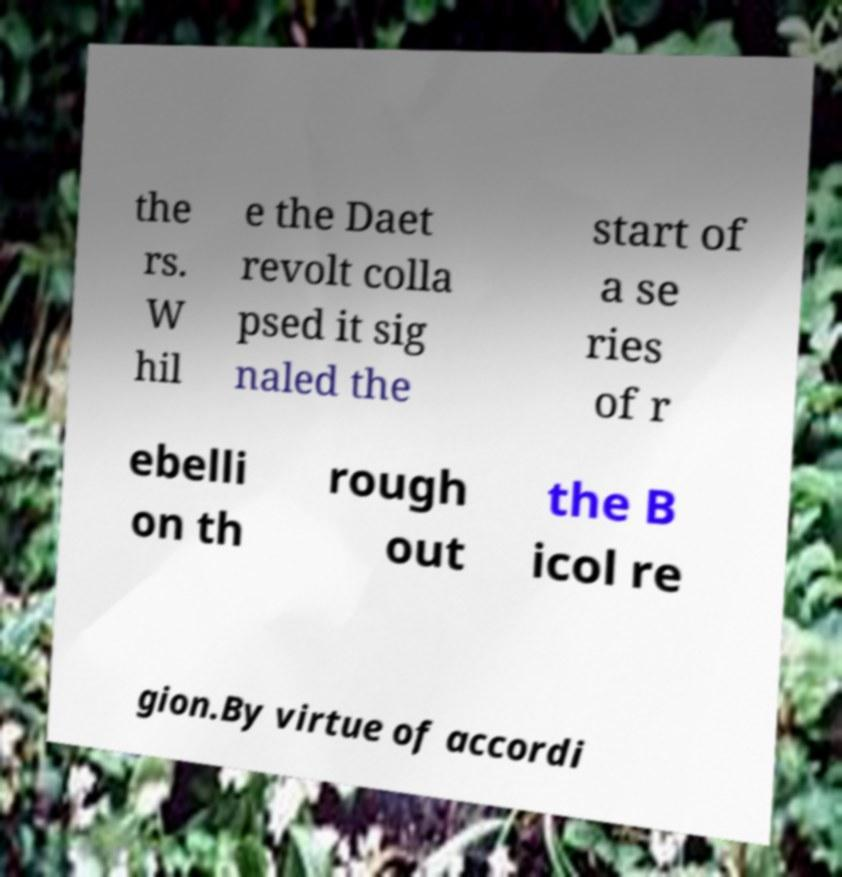Could you extract and type out the text from this image? the rs. W hil e the Daet revolt colla psed it sig naled the start of a se ries of r ebelli on th rough out the B icol re gion.By virtue of accordi 